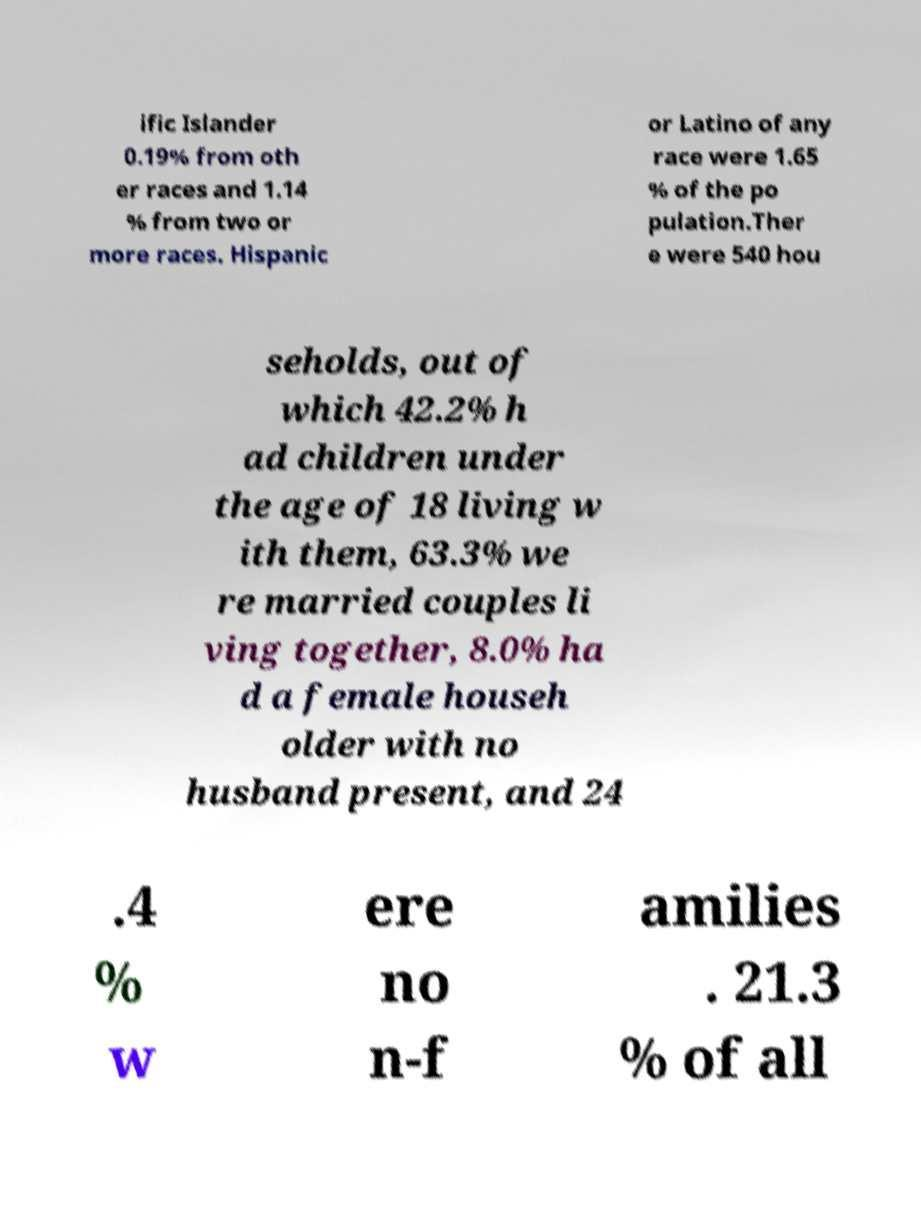Could you extract and type out the text from this image? ific Islander 0.19% from oth er races and 1.14 % from two or more races. Hispanic or Latino of any race were 1.65 % of the po pulation.Ther e were 540 hou seholds, out of which 42.2% h ad children under the age of 18 living w ith them, 63.3% we re married couples li ving together, 8.0% ha d a female househ older with no husband present, and 24 .4 % w ere no n-f amilies . 21.3 % of all 